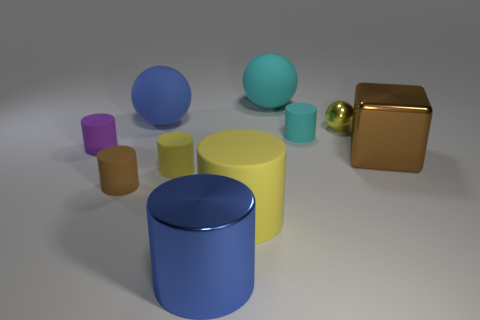What is the size of the yellow object behind the big cube behind the large matte cylinder?
Your answer should be very brief. Small. There is a big object that is on the right side of the blue ball and behind the tiny cyan thing; what is its material?
Give a very brief answer. Rubber. What color is the large rubber cylinder?
Make the answer very short. Yellow. Is there any other thing that is made of the same material as the purple thing?
Your answer should be very brief. Yes. There is a large blue object that is behind the yellow metal ball; what is its shape?
Give a very brief answer. Sphere. Are there any small matte objects left of the matte ball that is behind the big blue object behind the small brown cylinder?
Make the answer very short. Yes. Is there any other thing that is the same shape as the tiny purple object?
Make the answer very short. Yes. Are there any small brown matte cylinders?
Provide a short and direct response. Yes. Does the thing that is in front of the big yellow matte thing have the same material as the small yellow object that is in front of the brown metal block?
Keep it short and to the point. No. What size is the blue object that is in front of the large metallic object to the right of the cyan rubber object in front of the yellow ball?
Ensure brevity in your answer.  Large. 